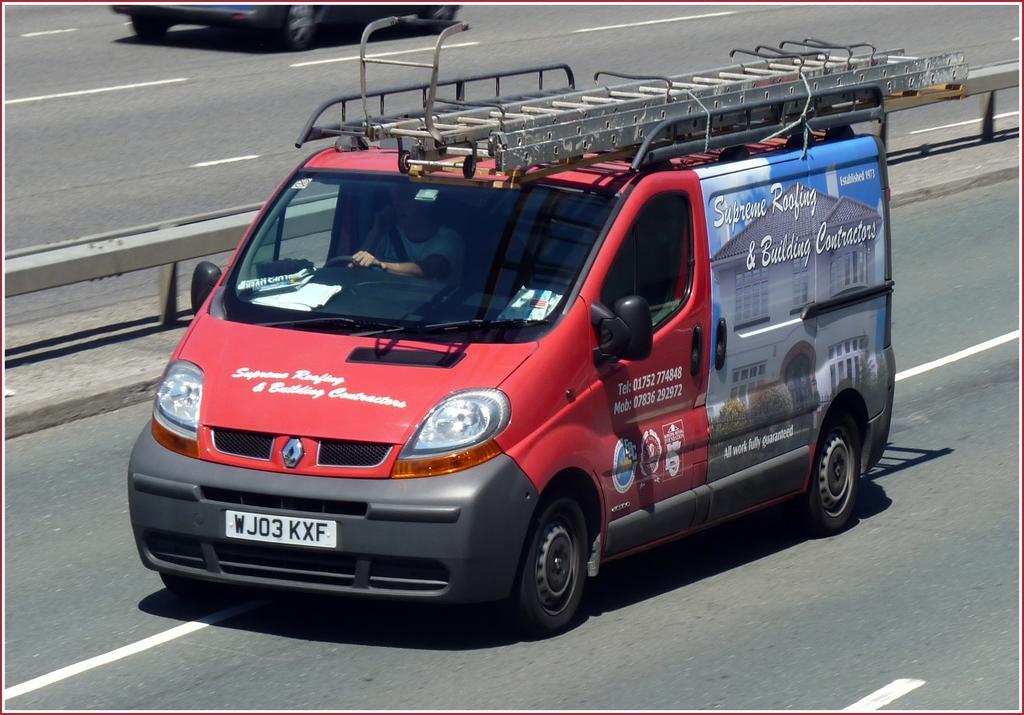Could you give a brief overview of what you see in this image? In the center of the image we can see a man is driving a truck. In the background of the image we can see the road, railing. At the top of the image we can see a vehicle. 